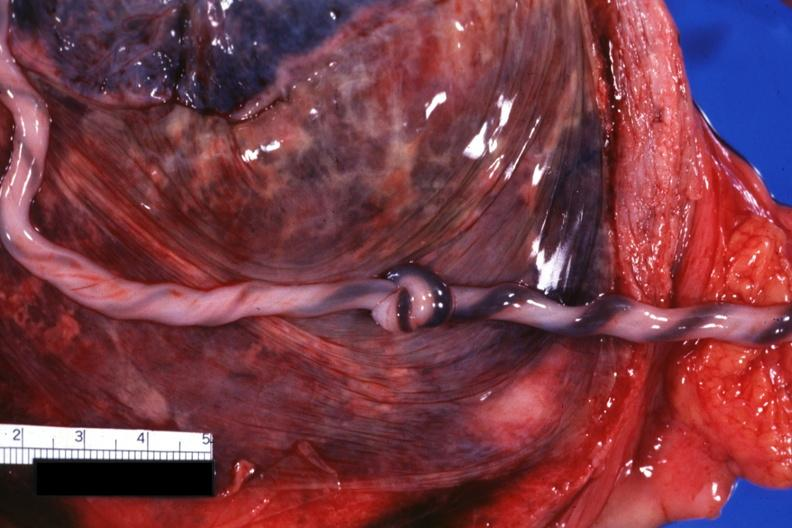what is present?
Answer the question using a single word or phrase. Female reproductive 